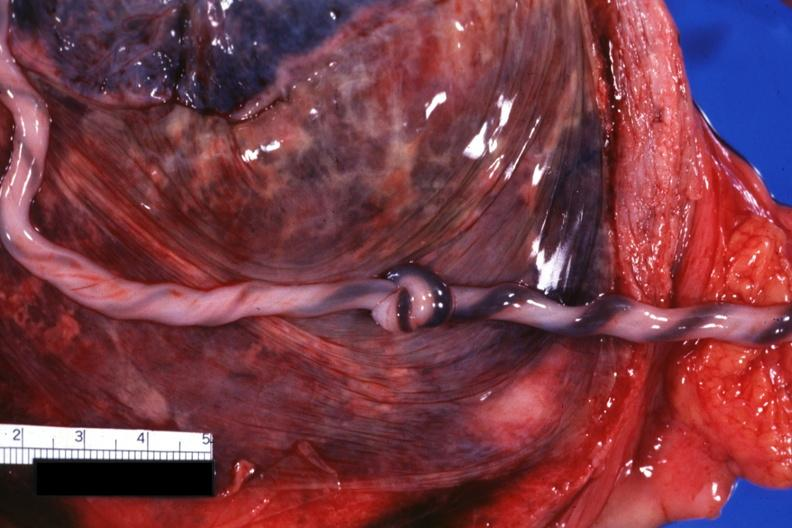what is present?
Answer the question using a single word or phrase. Female reproductive 